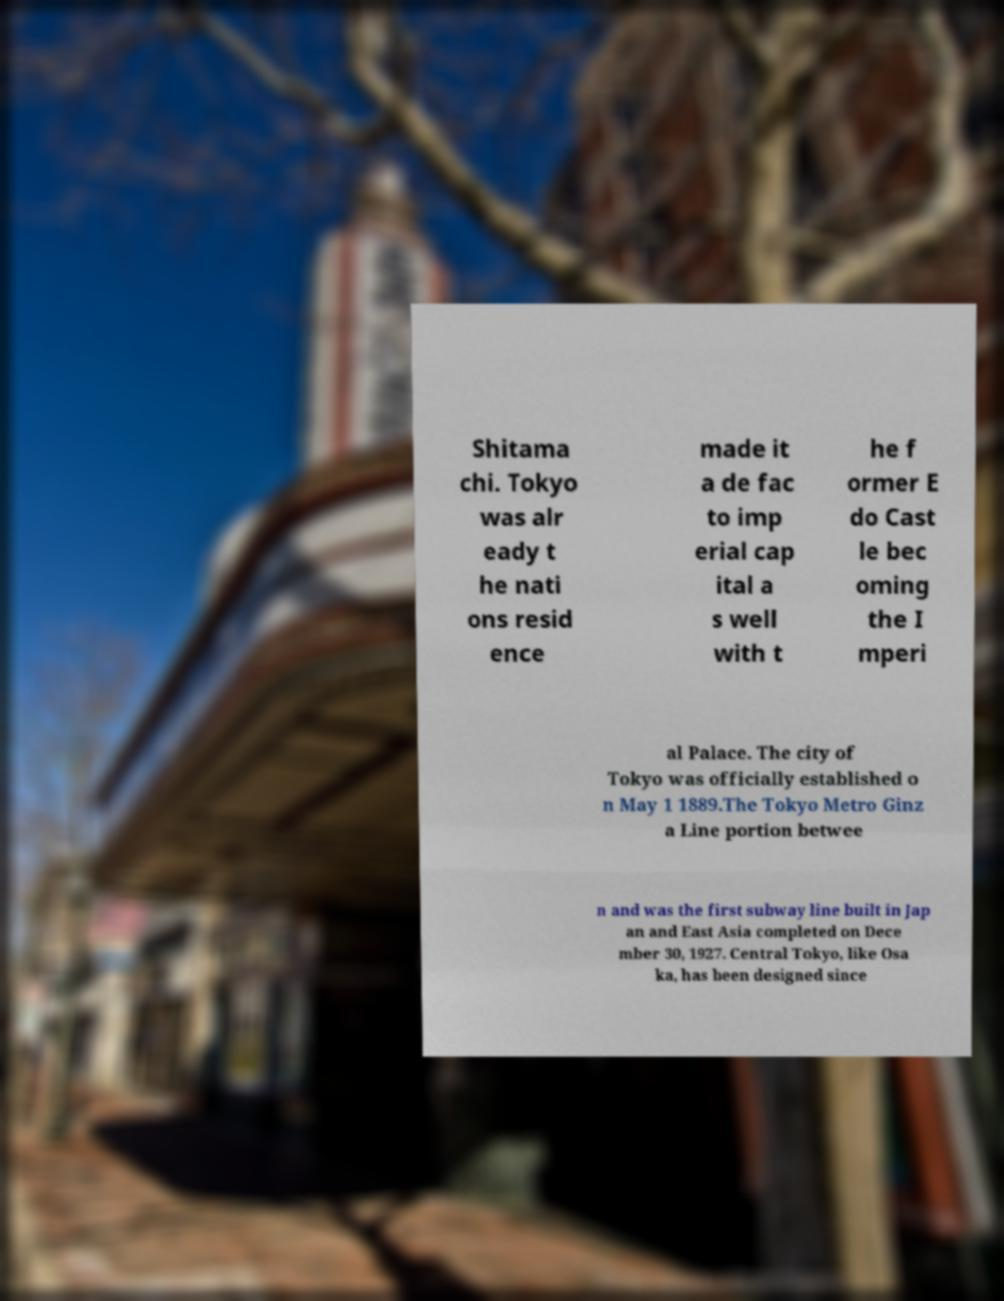For documentation purposes, I need the text within this image transcribed. Could you provide that? Shitama chi. Tokyo was alr eady t he nati ons resid ence made it a de fac to imp erial cap ital a s well with t he f ormer E do Cast le bec oming the I mperi al Palace. The city of Tokyo was officially established o n May 1 1889.The Tokyo Metro Ginz a Line portion betwee n and was the first subway line built in Jap an and East Asia completed on Dece mber 30, 1927. Central Tokyo, like Osa ka, has been designed since 